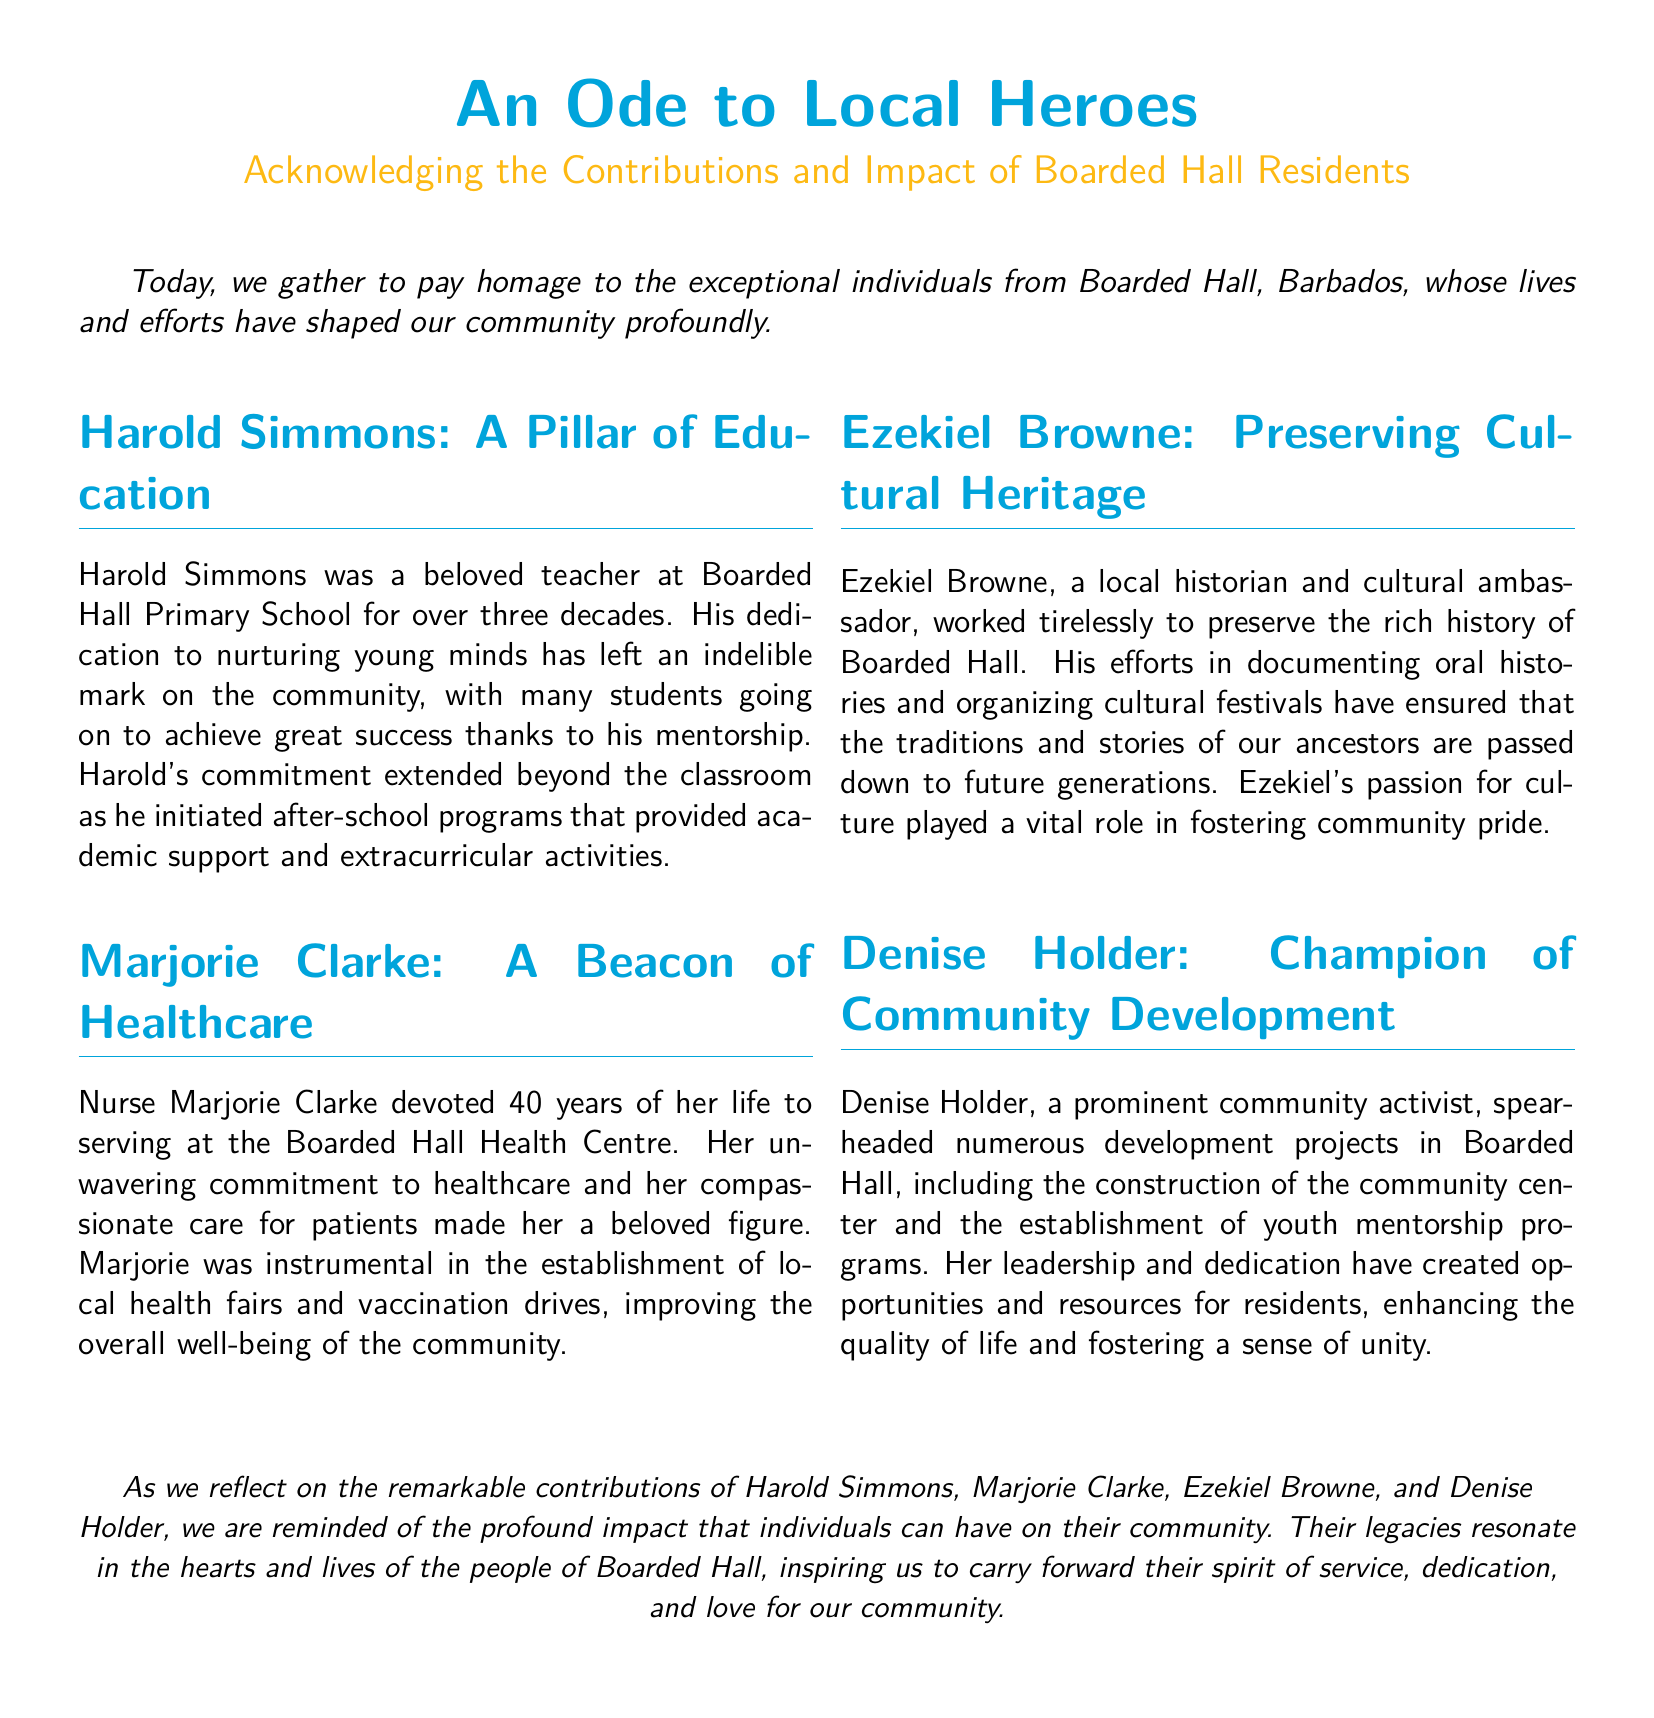What was Harold Simmons' profession? Harold Simmons was a beloved teacher, which is stated in the section about him.
Answer: Teacher How many years did Marjorie Clarke serve at the Boarded Hall Health Centre? The document specifies Marjorie Clarke devoted 40 years to her service at the health center.
Answer: 40 years What did Ezekiel Browne work to preserve? The document highlights Ezekiel Browne's efforts in preserving the rich history of Boarded Hall.
Answer: Cultural Heritage What community project did Denise Holder lead the construction of? The eulogy mentions that Denise Holder spearheaded the construction of the community center.
Answer: Community Center What is the overarching theme of the document? The document reflects on the contributions and impact of Boarded Hall residents, summarizing their efforts in various fields.
Answer: Local Heroes How did Harold Simmons support students outside the classroom? It is stated that Harold Simmons initiated after-school programs providing academic support and extracurricular activities.
Answer: After-school programs Which individual organized cultural festivals in the community? The text credits Ezekiel Browne for organizing cultural festivals as part of preserving the community's culture.
Answer: Ezekiel Browne What role did nursing play in Marjorie Clarke's life? The document indicates that Nurse Marjorie Clarke was dedicated to serving in healthcare for 40 years.
Answer: Healthcare What is the impact of the heroes mentioned in the document? The document says their legacies resonate in the hearts and lives of the people, inspiring us to carry forward their spirit.
Answer: Inspire Community 